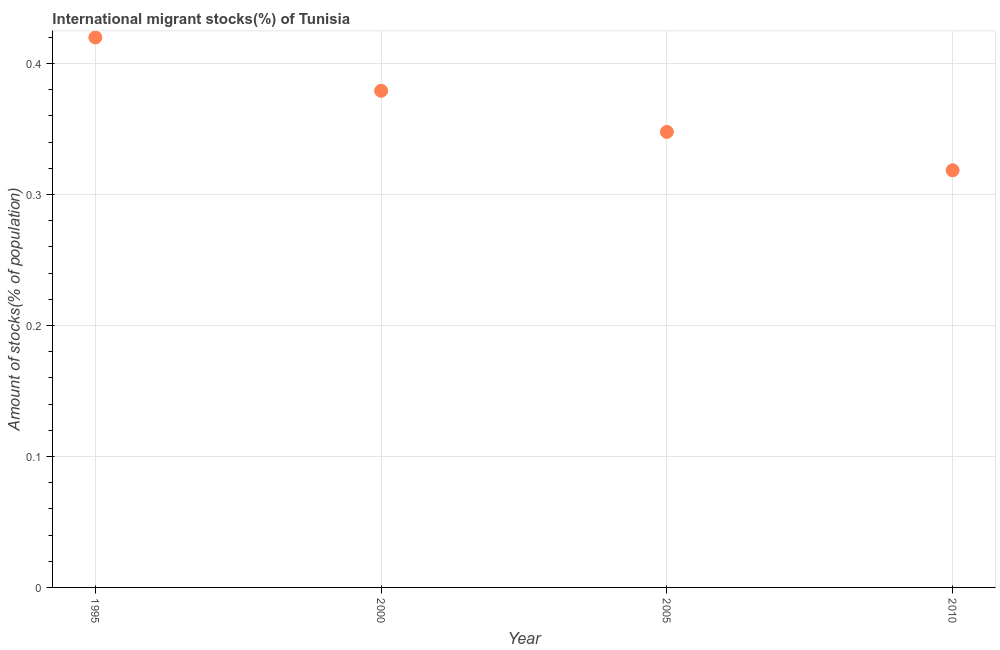What is the number of international migrant stocks in 1995?
Make the answer very short. 0.42. Across all years, what is the maximum number of international migrant stocks?
Offer a terse response. 0.42. Across all years, what is the minimum number of international migrant stocks?
Provide a succinct answer. 0.32. In which year was the number of international migrant stocks minimum?
Provide a succinct answer. 2010. What is the sum of the number of international migrant stocks?
Provide a short and direct response. 1.47. What is the difference between the number of international migrant stocks in 2000 and 2010?
Give a very brief answer. 0.06. What is the average number of international migrant stocks per year?
Keep it short and to the point. 0.37. What is the median number of international migrant stocks?
Provide a short and direct response. 0.36. In how many years, is the number of international migrant stocks greater than 0.2 %?
Provide a short and direct response. 4. What is the ratio of the number of international migrant stocks in 1995 to that in 2010?
Ensure brevity in your answer.  1.32. What is the difference between the highest and the second highest number of international migrant stocks?
Make the answer very short. 0.04. Is the sum of the number of international migrant stocks in 1995 and 2010 greater than the maximum number of international migrant stocks across all years?
Offer a very short reply. Yes. What is the difference between the highest and the lowest number of international migrant stocks?
Your answer should be compact. 0.1. In how many years, is the number of international migrant stocks greater than the average number of international migrant stocks taken over all years?
Your answer should be compact. 2. Does the number of international migrant stocks monotonically increase over the years?
Give a very brief answer. No. Does the graph contain any zero values?
Ensure brevity in your answer.  No. Does the graph contain grids?
Keep it short and to the point. Yes. What is the title of the graph?
Offer a terse response. International migrant stocks(%) of Tunisia. What is the label or title of the X-axis?
Offer a terse response. Year. What is the label or title of the Y-axis?
Your response must be concise. Amount of stocks(% of population). What is the Amount of stocks(% of population) in 1995?
Your response must be concise. 0.42. What is the Amount of stocks(% of population) in 2000?
Keep it short and to the point. 0.38. What is the Amount of stocks(% of population) in 2005?
Ensure brevity in your answer.  0.35. What is the Amount of stocks(% of population) in 2010?
Give a very brief answer. 0.32. What is the difference between the Amount of stocks(% of population) in 1995 and 2000?
Provide a succinct answer. 0.04. What is the difference between the Amount of stocks(% of population) in 1995 and 2005?
Offer a terse response. 0.07. What is the difference between the Amount of stocks(% of population) in 1995 and 2010?
Keep it short and to the point. 0.1. What is the difference between the Amount of stocks(% of population) in 2000 and 2005?
Your answer should be compact. 0.03. What is the difference between the Amount of stocks(% of population) in 2000 and 2010?
Your answer should be very brief. 0.06. What is the difference between the Amount of stocks(% of population) in 2005 and 2010?
Offer a terse response. 0.03. What is the ratio of the Amount of stocks(% of population) in 1995 to that in 2000?
Make the answer very short. 1.11. What is the ratio of the Amount of stocks(% of population) in 1995 to that in 2005?
Offer a very short reply. 1.21. What is the ratio of the Amount of stocks(% of population) in 1995 to that in 2010?
Give a very brief answer. 1.32. What is the ratio of the Amount of stocks(% of population) in 2000 to that in 2005?
Make the answer very short. 1.09. What is the ratio of the Amount of stocks(% of population) in 2000 to that in 2010?
Ensure brevity in your answer.  1.19. What is the ratio of the Amount of stocks(% of population) in 2005 to that in 2010?
Offer a very short reply. 1.09. 